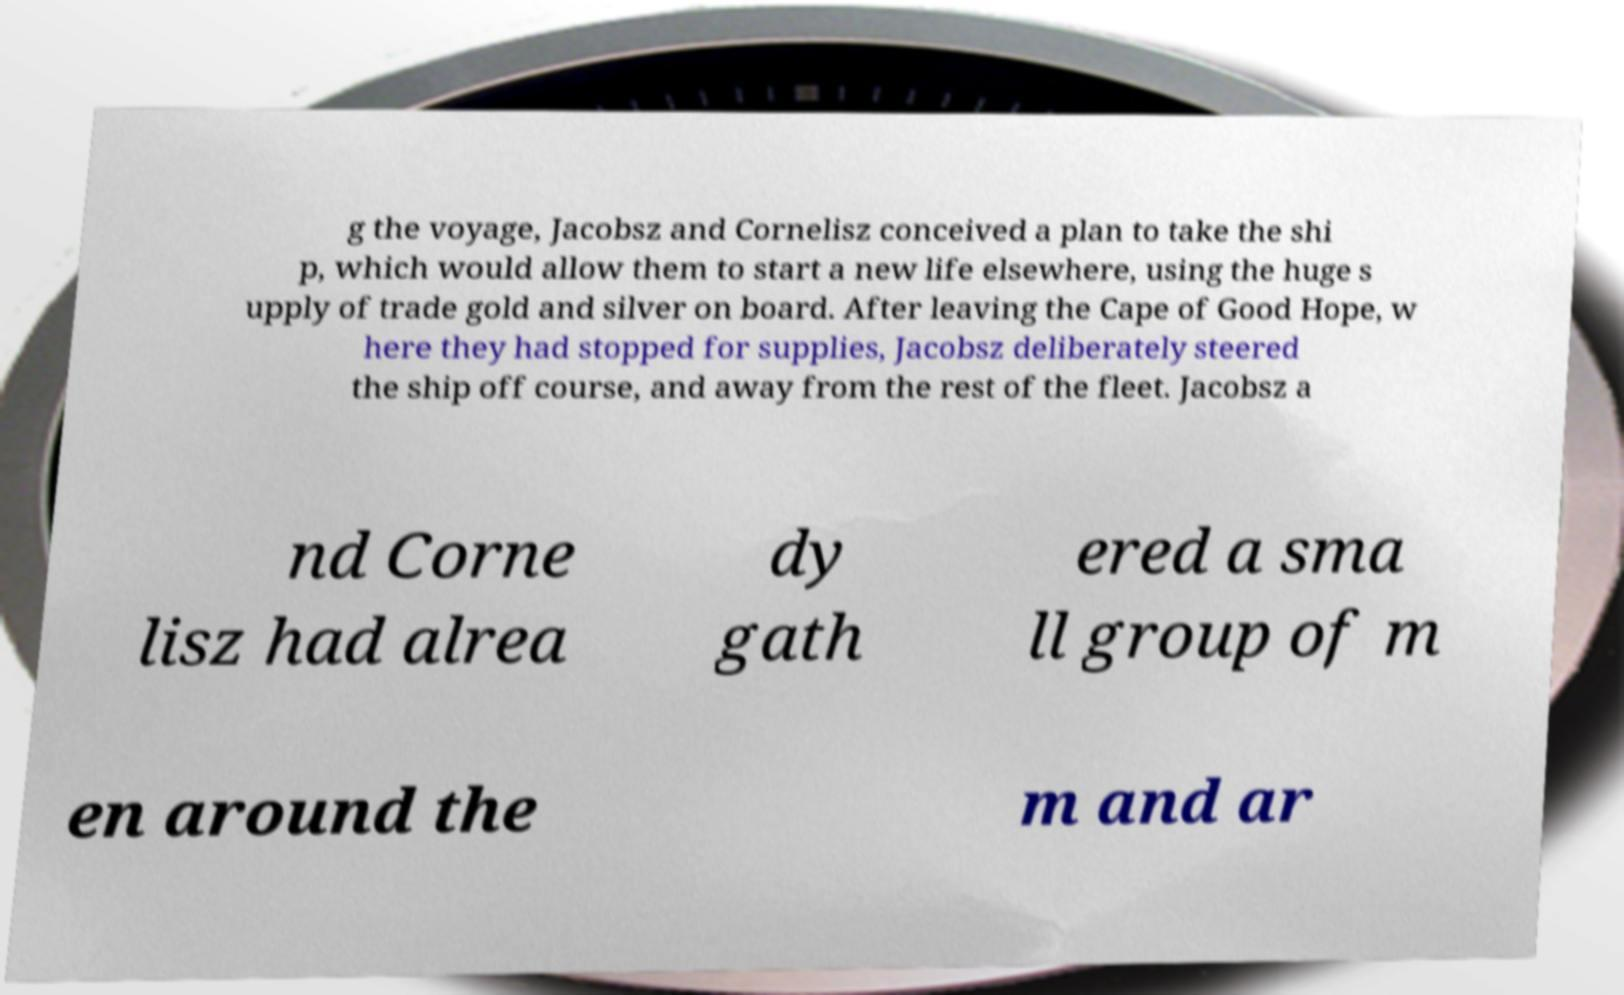Please read and relay the text visible in this image. What does it say? g the voyage, Jacobsz and Cornelisz conceived a plan to take the shi p, which would allow them to start a new life elsewhere, using the huge s upply of trade gold and silver on board. After leaving the Cape of Good Hope, w here they had stopped for supplies, Jacobsz deliberately steered the ship off course, and away from the rest of the fleet. Jacobsz a nd Corne lisz had alrea dy gath ered a sma ll group of m en around the m and ar 